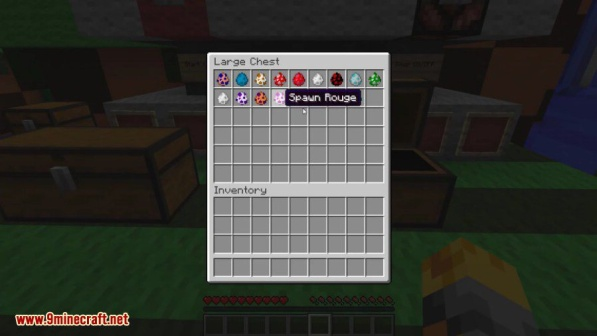If you could see into the past, what kind of adventures do you think the player experienced to gather these items? Peering into the past to understand the player's adventures that led to this varied collection of items, one can imagine numerous thrilling and diverse experiences. The player likely ventured deep into the mines, facing the dangers of the dark and battling hostile mobs to retrieve precious diamonds. They might have explored ancient libraries and strongholds to discover enchanted books filled with powerful spells.

During their journeys, the player probably stumbled upon enchanting forests and meadows, collecting delicate flowers and rare potions. The spawn eggs suggest that the player has interacted with mystical creatures, perhaps finding them in far-off biomes or hidden dungeons. Each item tells a story of survival, exploration, and mastery in the expansive world of Minecraft.

The player likely crafted and utilized various tools and armor, combining resources from different biomes and structures they encountered along their way. Their adventures could have included battles with formidable foes, alliances with villagers, and the discovery of hidden treasures. All these experiences culminate in the rich, diverse inventory seen in the snapshot, each item representing a unique part of the player's epic Minecraft saga. Can you create a whimsical story about the flower in the chest? Once upon a time in the pixelated world of Minecraft, there was a flower unlike any other. This delicate bloom, known as the Enchanted Azure Bluet, was whispered about in legends across many biomes. It was said that the flower had the power to bring peaceful dreams and calm to any soul who held it.

One day, as the player was journeying through a mystical forest, they stumbled upon an ancient, hidden grove. The grove glowed with an ethereal light, and at its center stood the Enchanted Azure Bluet, surrounded by singing birds and fluttering butterflies. The player knew that this was no ordinary flower—it was a gift from the forest spirits who watched over the land.

With great care, the player plucked the flower and placed it gently in their chest, knowing its magic would be a token of peace and wonder in their travels. Whenever the player felt lost or weary, they would take a moment to admire the Enchanted Azure Bluet, drawing strength from its serene presence.

Little did the player know, the flower's magic extended beyond simple comfort. One night, as the player gazed upon the bloom, they were transported to a dreamlike realm where trees danced and rivers sang. In this magical place, they met the spirit of the forest who offered wisdom and guidance for their adventures ahead.

With newfound vigor and the Enchanted Azure Bluet by their side, the player continued their journey, knowing that the flower was a bridge between the world of the living and the enchanting mysteries beyond. And so, the flower remained a cherished companion, a symbol of the magic that lies hidden in the wild places of Minecraft. 